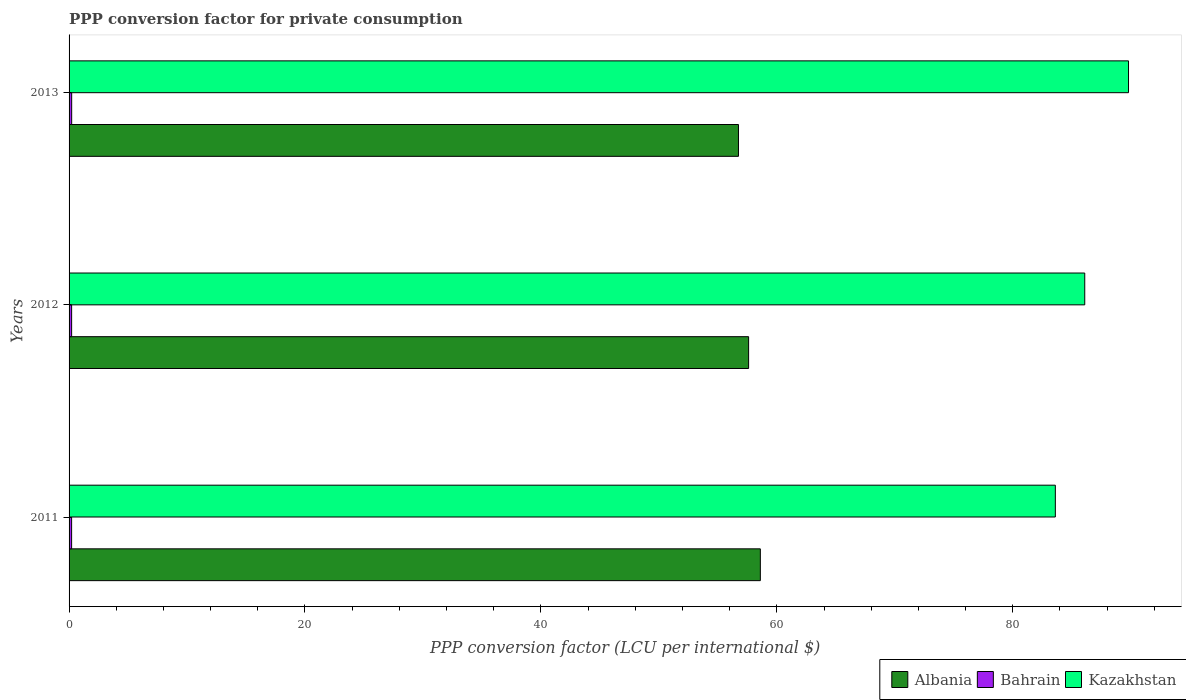How many groups of bars are there?
Make the answer very short. 3. Are the number of bars per tick equal to the number of legend labels?
Ensure brevity in your answer.  Yes. Are the number of bars on each tick of the Y-axis equal?
Offer a terse response. Yes. How many bars are there on the 1st tick from the bottom?
Keep it short and to the point. 3. In how many cases, is the number of bars for a given year not equal to the number of legend labels?
Offer a terse response. 0. What is the PPP conversion factor for private consumption in Kazakhstan in 2013?
Your answer should be very brief. 89.82. Across all years, what is the maximum PPP conversion factor for private consumption in Kazakhstan?
Offer a terse response. 89.82. Across all years, what is the minimum PPP conversion factor for private consumption in Bahrain?
Offer a terse response. 0.22. In which year was the PPP conversion factor for private consumption in Bahrain maximum?
Provide a succinct answer. 2013. In which year was the PPP conversion factor for private consumption in Kazakhstan minimum?
Offer a terse response. 2011. What is the total PPP conversion factor for private consumption in Bahrain in the graph?
Ensure brevity in your answer.  0.65. What is the difference between the PPP conversion factor for private consumption in Albania in 2011 and that in 2013?
Ensure brevity in your answer.  1.85. What is the difference between the PPP conversion factor for private consumption in Kazakhstan in 2013 and the PPP conversion factor for private consumption in Bahrain in 2012?
Give a very brief answer. 89.6. What is the average PPP conversion factor for private consumption in Albania per year?
Provide a short and direct response. 57.65. In the year 2013, what is the difference between the PPP conversion factor for private consumption in Kazakhstan and PPP conversion factor for private consumption in Albania?
Keep it short and to the point. 33.07. What is the ratio of the PPP conversion factor for private consumption in Bahrain in 2011 to that in 2012?
Keep it short and to the point. 0.99. Is the difference between the PPP conversion factor for private consumption in Kazakhstan in 2012 and 2013 greater than the difference between the PPP conversion factor for private consumption in Albania in 2012 and 2013?
Your response must be concise. No. What is the difference between the highest and the second highest PPP conversion factor for private consumption in Kazakhstan?
Ensure brevity in your answer.  3.71. What is the difference between the highest and the lowest PPP conversion factor for private consumption in Albania?
Keep it short and to the point. 1.85. What does the 3rd bar from the top in 2013 represents?
Offer a very short reply. Albania. What does the 3rd bar from the bottom in 2012 represents?
Keep it short and to the point. Kazakhstan. Are all the bars in the graph horizontal?
Ensure brevity in your answer.  Yes. What is the difference between two consecutive major ticks on the X-axis?
Give a very brief answer. 20. Does the graph contain grids?
Ensure brevity in your answer.  No. How many legend labels are there?
Provide a short and direct response. 3. What is the title of the graph?
Give a very brief answer. PPP conversion factor for private consumption. Does "Tanzania" appear as one of the legend labels in the graph?
Ensure brevity in your answer.  No. What is the label or title of the X-axis?
Make the answer very short. PPP conversion factor (LCU per international $). What is the label or title of the Y-axis?
Your answer should be compact. Years. What is the PPP conversion factor (LCU per international $) of Albania in 2011?
Your answer should be very brief. 58.6. What is the PPP conversion factor (LCU per international $) in Bahrain in 2011?
Ensure brevity in your answer.  0.22. What is the PPP conversion factor (LCU per international $) of Kazakhstan in 2011?
Provide a short and direct response. 83.61. What is the PPP conversion factor (LCU per international $) of Albania in 2012?
Offer a terse response. 57.61. What is the PPP conversion factor (LCU per international $) of Bahrain in 2012?
Provide a succinct answer. 0.22. What is the PPP conversion factor (LCU per international $) of Kazakhstan in 2012?
Your response must be concise. 86.11. What is the PPP conversion factor (LCU per international $) of Albania in 2013?
Provide a short and direct response. 56.75. What is the PPP conversion factor (LCU per international $) in Bahrain in 2013?
Give a very brief answer. 0.22. What is the PPP conversion factor (LCU per international $) in Kazakhstan in 2013?
Provide a succinct answer. 89.82. Across all years, what is the maximum PPP conversion factor (LCU per international $) in Albania?
Make the answer very short. 58.6. Across all years, what is the maximum PPP conversion factor (LCU per international $) of Bahrain?
Provide a short and direct response. 0.22. Across all years, what is the maximum PPP conversion factor (LCU per international $) in Kazakhstan?
Provide a succinct answer. 89.82. Across all years, what is the minimum PPP conversion factor (LCU per international $) in Albania?
Ensure brevity in your answer.  56.75. Across all years, what is the minimum PPP conversion factor (LCU per international $) in Bahrain?
Your answer should be very brief. 0.22. Across all years, what is the minimum PPP conversion factor (LCU per international $) in Kazakhstan?
Provide a succinct answer. 83.61. What is the total PPP conversion factor (LCU per international $) of Albania in the graph?
Give a very brief answer. 172.96. What is the total PPP conversion factor (LCU per international $) in Bahrain in the graph?
Offer a terse response. 0.65. What is the total PPP conversion factor (LCU per international $) of Kazakhstan in the graph?
Make the answer very short. 259.53. What is the difference between the PPP conversion factor (LCU per international $) in Bahrain in 2011 and that in 2012?
Make the answer very short. -0. What is the difference between the PPP conversion factor (LCU per international $) of Kazakhstan in 2011 and that in 2012?
Your answer should be compact. -2.49. What is the difference between the PPP conversion factor (LCU per international $) in Albania in 2011 and that in 2013?
Make the answer very short. 1.85. What is the difference between the PPP conversion factor (LCU per international $) of Bahrain in 2011 and that in 2013?
Provide a short and direct response. -0.01. What is the difference between the PPP conversion factor (LCU per international $) in Kazakhstan in 2011 and that in 2013?
Offer a terse response. -6.2. What is the difference between the PPP conversion factor (LCU per international $) in Albania in 2012 and that in 2013?
Provide a succinct answer. 0.86. What is the difference between the PPP conversion factor (LCU per international $) in Bahrain in 2012 and that in 2013?
Give a very brief answer. -0. What is the difference between the PPP conversion factor (LCU per international $) in Kazakhstan in 2012 and that in 2013?
Keep it short and to the point. -3.71. What is the difference between the PPP conversion factor (LCU per international $) in Albania in 2011 and the PPP conversion factor (LCU per international $) in Bahrain in 2012?
Offer a very short reply. 58.39. What is the difference between the PPP conversion factor (LCU per international $) in Albania in 2011 and the PPP conversion factor (LCU per international $) in Kazakhstan in 2012?
Your answer should be compact. -27.5. What is the difference between the PPP conversion factor (LCU per international $) of Bahrain in 2011 and the PPP conversion factor (LCU per international $) of Kazakhstan in 2012?
Give a very brief answer. -85.89. What is the difference between the PPP conversion factor (LCU per international $) of Albania in 2011 and the PPP conversion factor (LCU per international $) of Bahrain in 2013?
Keep it short and to the point. 58.38. What is the difference between the PPP conversion factor (LCU per international $) of Albania in 2011 and the PPP conversion factor (LCU per international $) of Kazakhstan in 2013?
Your response must be concise. -31.21. What is the difference between the PPP conversion factor (LCU per international $) of Bahrain in 2011 and the PPP conversion factor (LCU per international $) of Kazakhstan in 2013?
Offer a very short reply. -89.6. What is the difference between the PPP conversion factor (LCU per international $) of Albania in 2012 and the PPP conversion factor (LCU per international $) of Bahrain in 2013?
Provide a succinct answer. 57.39. What is the difference between the PPP conversion factor (LCU per international $) of Albania in 2012 and the PPP conversion factor (LCU per international $) of Kazakhstan in 2013?
Ensure brevity in your answer.  -32.21. What is the difference between the PPP conversion factor (LCU per international $) in Bahrain in 2012 and the PPP conversion factor (LCU per international $) in Kazakhstan in 2013?
Your response must be concise. -89.6. What is the average PPP conversion factor (LCU per international $) of Albania per year?
Your answer should be very brief. 57.65. What is the average PPP conversion factor (LCU per international $) in Bahrain per year?
Offer a very short reply. 0.22. What is the average PPP conversion factor (LCU per international $) of Kazakhstan per year?
Keep it short and to the point. 86.51. In the year 2011, what is the difference between the PPP conversion factor (LCU per international $) of Albania and PPP conversion factor (LCU per international $) of Bahrain?
Ensure brevity in your answer.  58.39. In the year 2011, what is the difference between the PPP conversion factor (LCU per international $) in Albania and PPP conversion factor (LCU per international $) in Kazakhstan?
Your answer should be very brief. -25.01. In the year 2011, what is the difference between the PPP conversion factor (LCU per international $) in Bahrain and PPP conversion factor (LCU per international $) in Kazakhstan?
Your answer should be compact. -83.4. In the year 2012, what is the difference between the PPP conversion factor (LCU per international $) of Albania and PPP conversion factor (LCU per international $) of Bahrain?
Your response must be concise. 57.39. In the year 2012, what is the difference between the PPP conversion factor (LCU per international $) in Albania and PPP conversion factor (LCU per international $) in Kazakhstan?
Your answer should be compact. -28.5. In the year 2012, what is the difference between the PPP conversion factor (LCU per international $) of Bahrain and PPP conversion factor (LCU per international $) of Kazakhstan?
Your answer should be very brief. -85.89. In the year 2013, what is the difference between the PPP conversion factor (LCU per international $) in Albania and PPP conversion factor (LCU per international $) in Bahrain?
Provide a succinct answer. 56.53. In the year 2013, what is the difference between the PPP conversion factor (LCU per international $) in Albania and PPP conversion factor (LCU per international $) in Kazakhstan?
Offer a very short reply. -33.07. In the year 2013, what is the difference between the PPP conversion factor (LCU per international $) in Bahrain and PPP conversion factor (LCU per international $) in Kazakhstan?
Make the answer very short. -89.59. What is the ratio of the PPP conversion factor (LCU per international $) in Albania in 2011 to that in 2012?
Give a very brief answer. 1.02. What is the ratio of the PPP conversion factor (LCU per international $) in Bahrain in 2011 to that in 2012?
Make the answer very short. 0.99. What is the ratio of the PPP conversion factor (LCU per international $) in Albania in 2011 to that in 2013?
Keep it short and to the point. 1.03. What is the ratio of the PPP conversion factor (LCU per international $) of Bahrain in 2011 to that in 2013?
Keep it short and to the point. 0.98. What is the ratio of the PPP conversion factor (LCU per international $) of Kazakhstan in 2011 to that in 2013?
Provide a succinct answer. 0.93. What is the ratio of the PPP conversion factor (LCU per international $) in Albania in 2012 to that in 2013?
Ensure brevity in your answer.  1.02. What is the ratio of the PPP conversion factor (LCU per international $) of Bahrain in 2012 to that in 2013?
Keep it short and to the point. 0.98. What is the ratio of the PPP conversion factor (LCU per international $) in Kazakhstan in 2012 to that in 2013?
Ensure brevity in your answer.  0.96. What is the difference between the highest and the second highest PPP conversion factor (LCU per international $) of Albania?
Ensure brevity in your answer.  1. What is the difference between the highest and the second highest PPP conversion factor (LCU per international $) in Bahrain?
Your answer should be very brief. 0. What is the difference between the highest and the second highest PPP conversion factor (LCU per international $) in Kazakhstan?
Your response must be concise. 3.71. What is the difference between the highest and the lowest PPP conversion factor (LCU per international $) of Albania?
Provide a succinct answer. 1.85. What is the difference between the highest and the lowest PPP conversion factor (LCU per international $) of Bahrain?
Your answer should be compact. 0.01. What is the difference between the highest and the lowest PPP conversion factor (LCU per international $) in Kazakhstan?
Offer a very short reply. 6.2. 